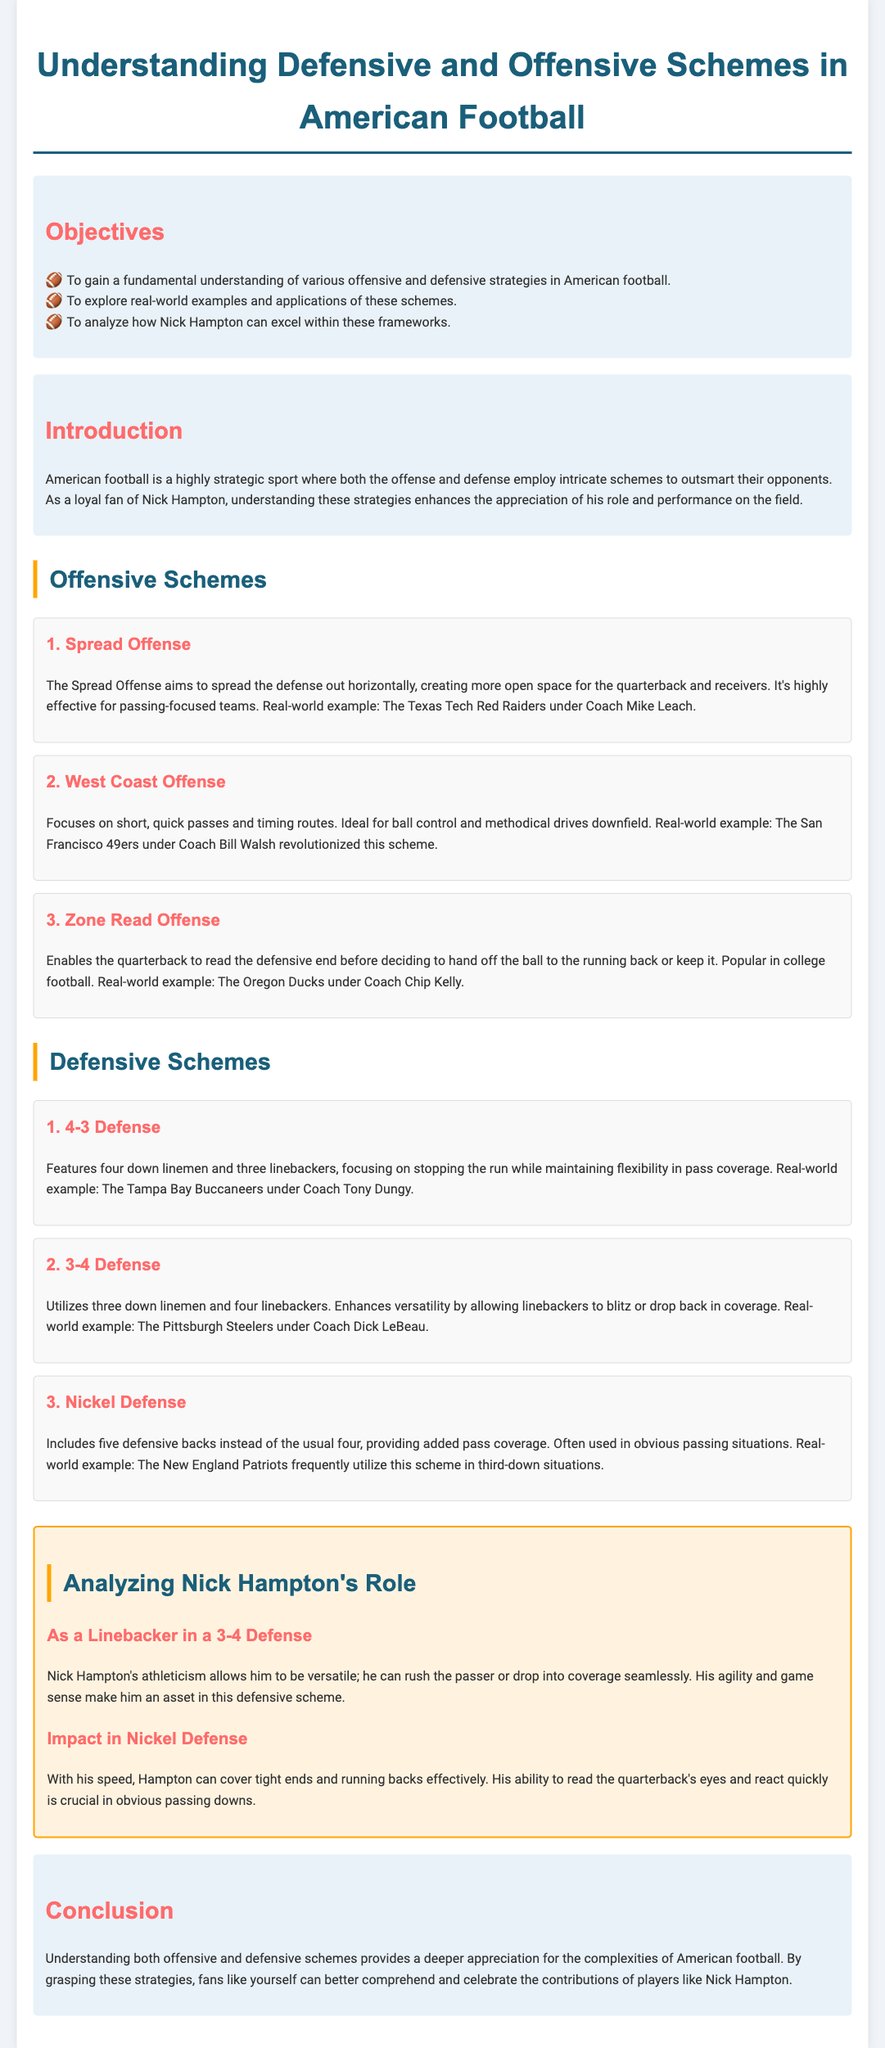What is the title of the lesson plan? The title clearly outlines the main subject of the lesson plan, which is provided at the top of the document.
Answer: Understanding Defensive and Offensive Schemes in American Football What is one objective of the lesson? The document lists several objectives, specifically aimed at understanding football strategies and analyzing Nick Hampton's performance.
Answer: To gain a fundamental understanding of various offensive and defensive strategies in American football Which offensive scheme focuses on short, quick passes? The description of the offensive schemes includes details about their focus, specifically pointing out the emphasis of the West Coast Offense.
Answer: West Coast Offense How many defensive backs does the Nickel Defense typically include? The document specifies the number of defensive backs in the Nickel Defense, distinguishing it from other defensive schemes.
Answer: Five What is the real-world example given for the 3-4 Defense? The document includes specific teams as examples for each scheme, highlighting the Pittsburgh Steelers as a key example for this defensive strategy.
Answer: Pittsburgh Steelers Why is Nick Hampton considered an asset in the 3-4 Defense? The analysis section discusses Hampton's skills and attributes that enhance his effectiveness within the defensive scheme.
Answer: His athleticism allows him to be versatile What examples are provided for a passing-focused offensive scheme? The document lists specific teams as real-world examples, particularly for offensive schemes that emphasize passing strategies.
Answer: Texas Tech Red Raiders What does the conclusion emphasize regarding understanding football schemes? The conclusion summarizes the importance of understanding schemes, reinforcing the overall theme presented in the document.
Answer: Provides a deeper appreciation for the complexities of American football 